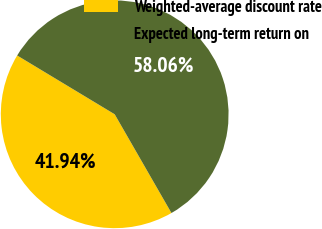<chart> <loc_0><loc_0><loc_500><loc_500><pie_chart><fcel>Weighted-average discount rate<fcel>Expected long-term return on<nl><fcel>41.94%<fcel>58.06%<nl></chart> 